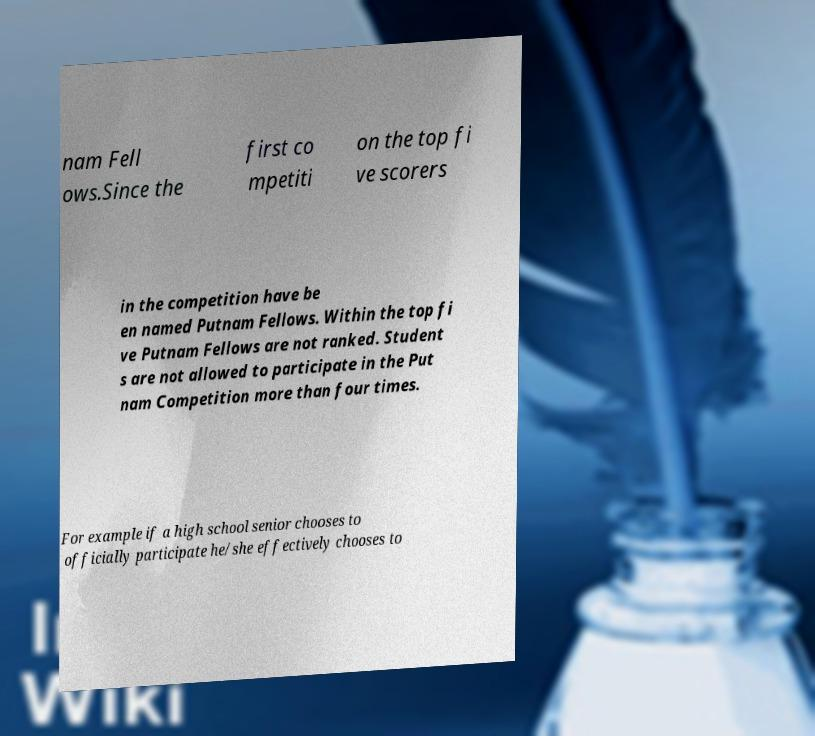Could you assist in decoding the text presented in this image and type it out clearly? nam Fell ows.Since the first co mpetiti on the top fi ve scorers in the competition have be en named Putnam Fellows. Within the top fi ve Putnam Fellows are not ranked. Student s are not allowed to participate in the Put nam Competition more than four times. For example if a high school senior chooses to officially participate he/she effectively chooses to 